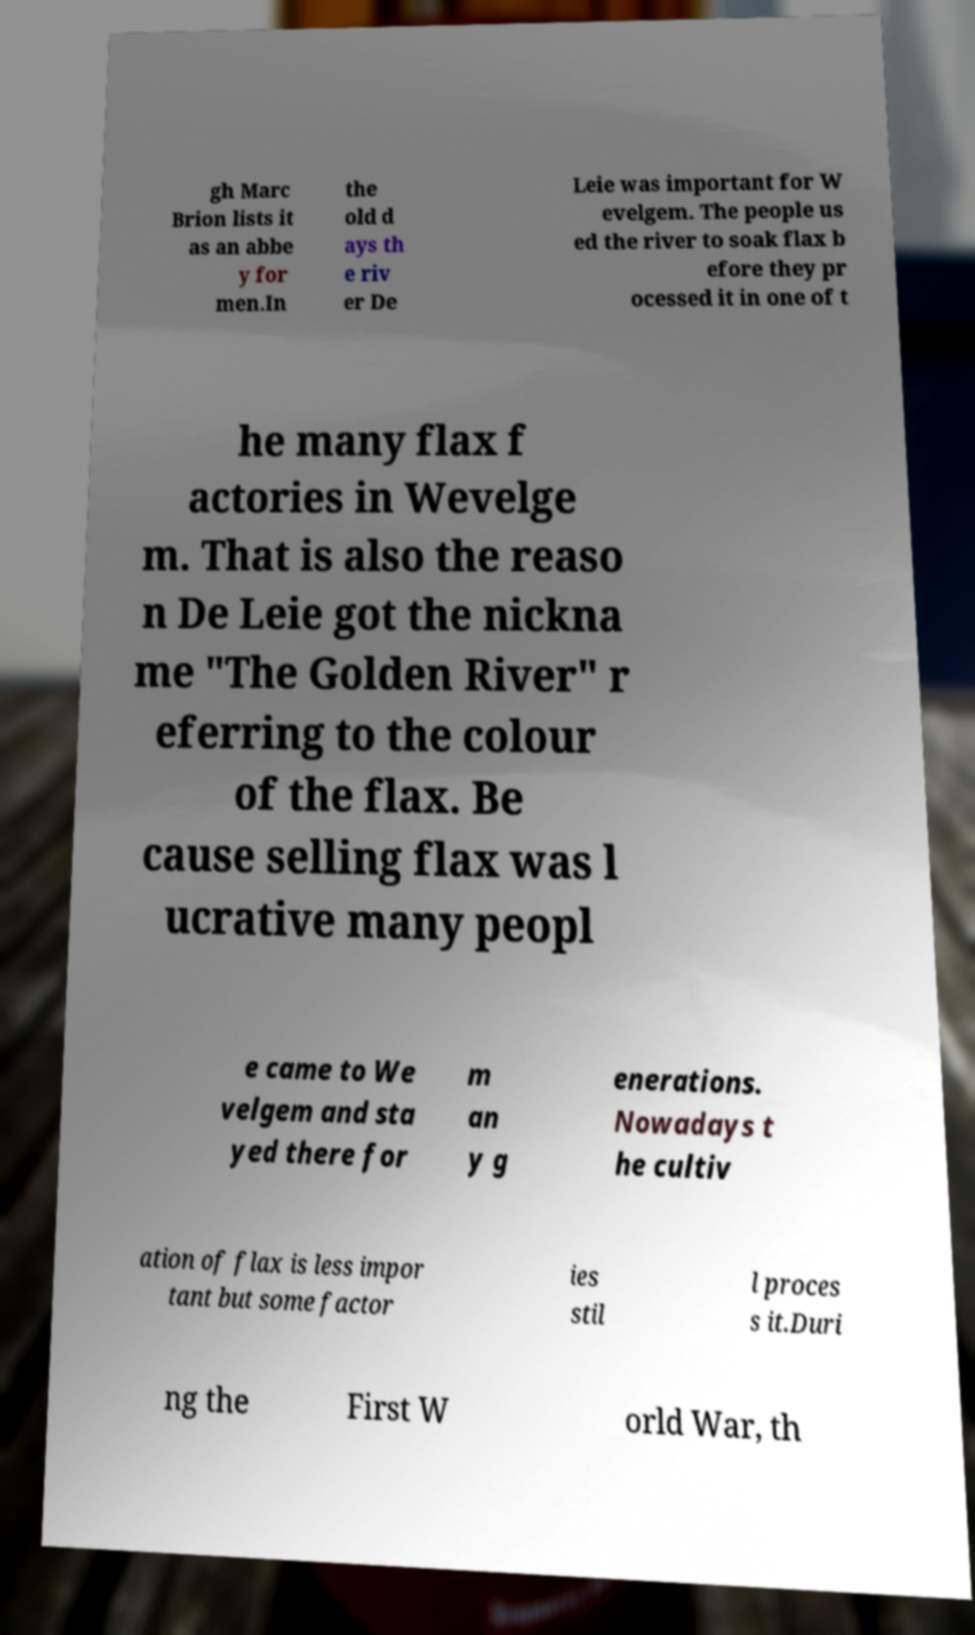Could you extract and type out the text from this image? gh Marc Brion lists it as an abbe y for men.In the old d ays th e riv er De Leie was important for W evelgem. The people us ed the river to soak flax b efore they pr ocessed it in one of t he many flax f actories in Wevelge m. That is also the reaso n De Leie got the nickna me "The Golden River" r eferring to the colour of the flax. Be cause selling flax was l ucrative many peopl e came to We velgem and sta yed there for m an y g enerations. Nowadays t he cultiv ation of flax is less impor tant but some factor ies stil l proces s it.Duri ng the First W orld War, th 